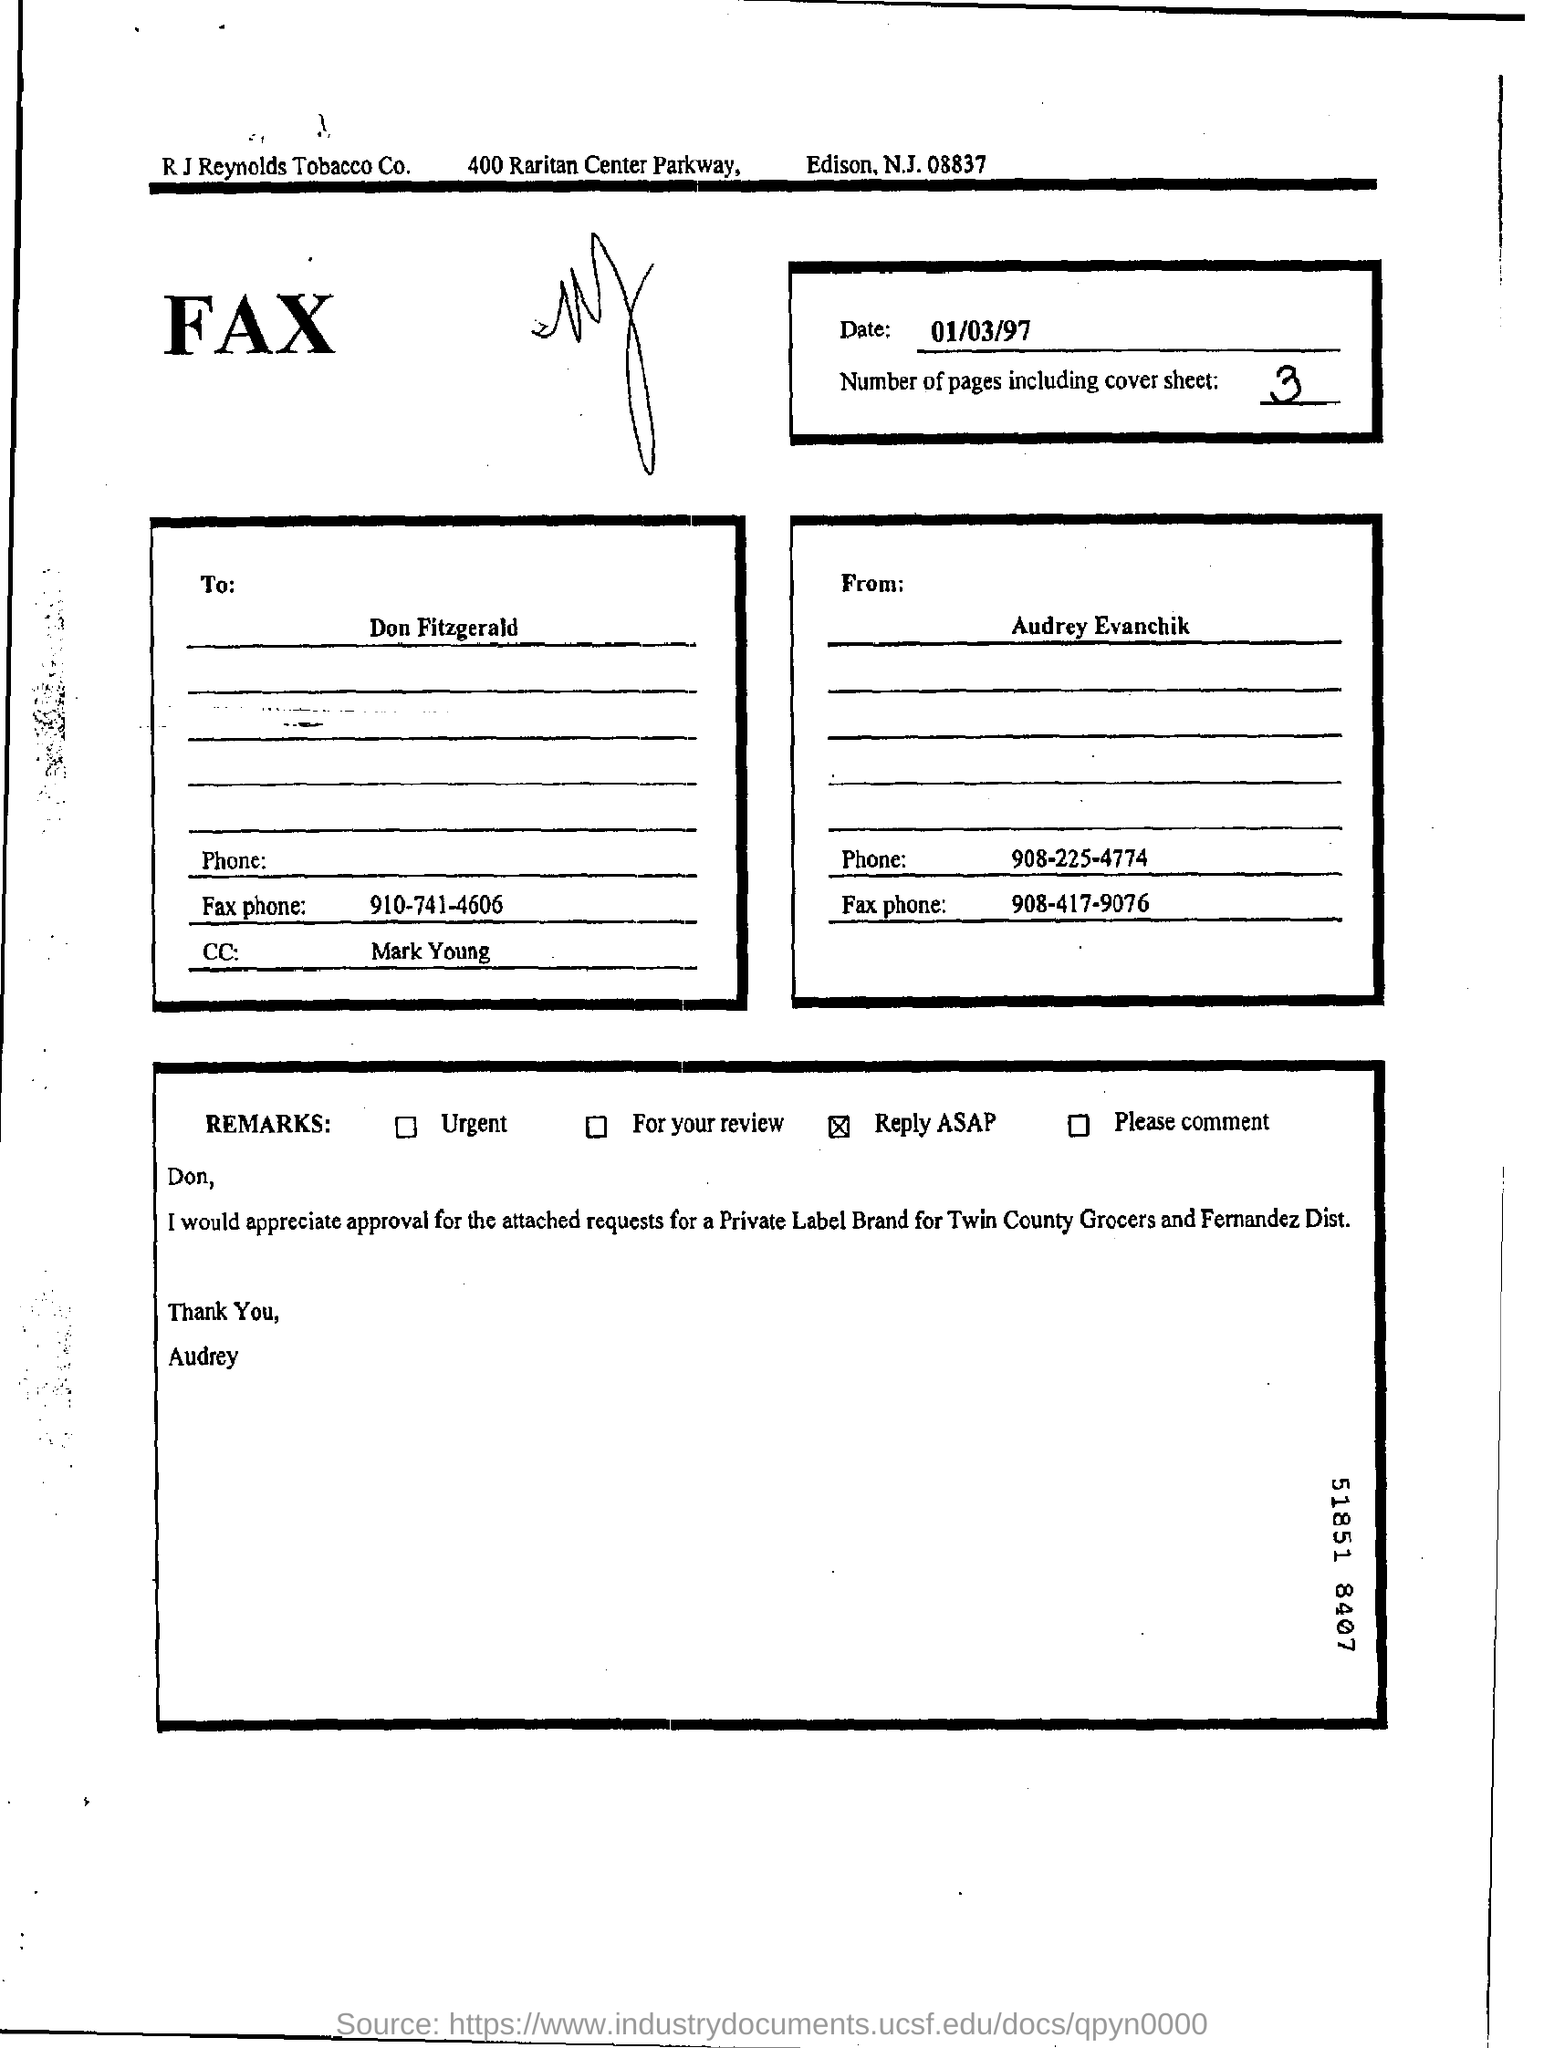Outline some significant characteristics in this image. The phone number of Audrey is 908-225-4774. This fax is from Audrey Evanchik. The recipient of the fax is Don Fitzgerald. The date of the fax is January 3, 1997. Under the "Remarks" option, please select the appropriate response. 